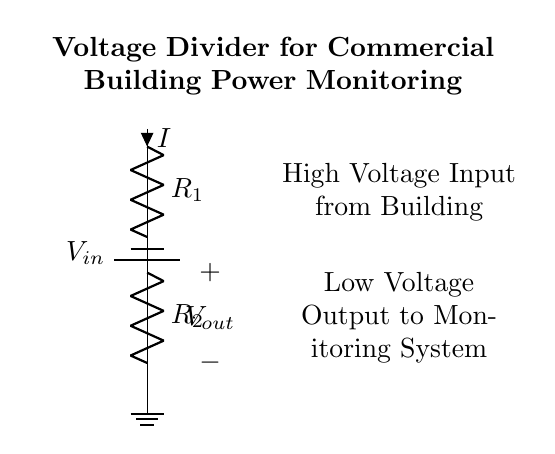What is the input voltage in the circuit? The input voltage is indicated at the top left of the circuit as V in
Answer: V in What are the resistor labels in the circuit? The resistors are labeled R one and R two, showing their positions in the voltage divider
Answer: R one and R two What is the purpose of the voltage divider in this circuit? The purpose is to reduce the high input voltage to a lower output voltage for monitoring
Answer: To reduce voltage What is the current flowing through R one? The current is labeled as I, which means the current flowing through the resistor R one
Answer: I What is the output voltage in relation to the resistors? The output voltage V out is determined by the ratio of R one and R two according to the voltage divider rule
Answer: V out is based on R one and R two How does changing R one affect V out? Increasing R one will increase V out, while decreasing R one will lower V out, according to the voltage divider formula
Answer: V out changes with R one 